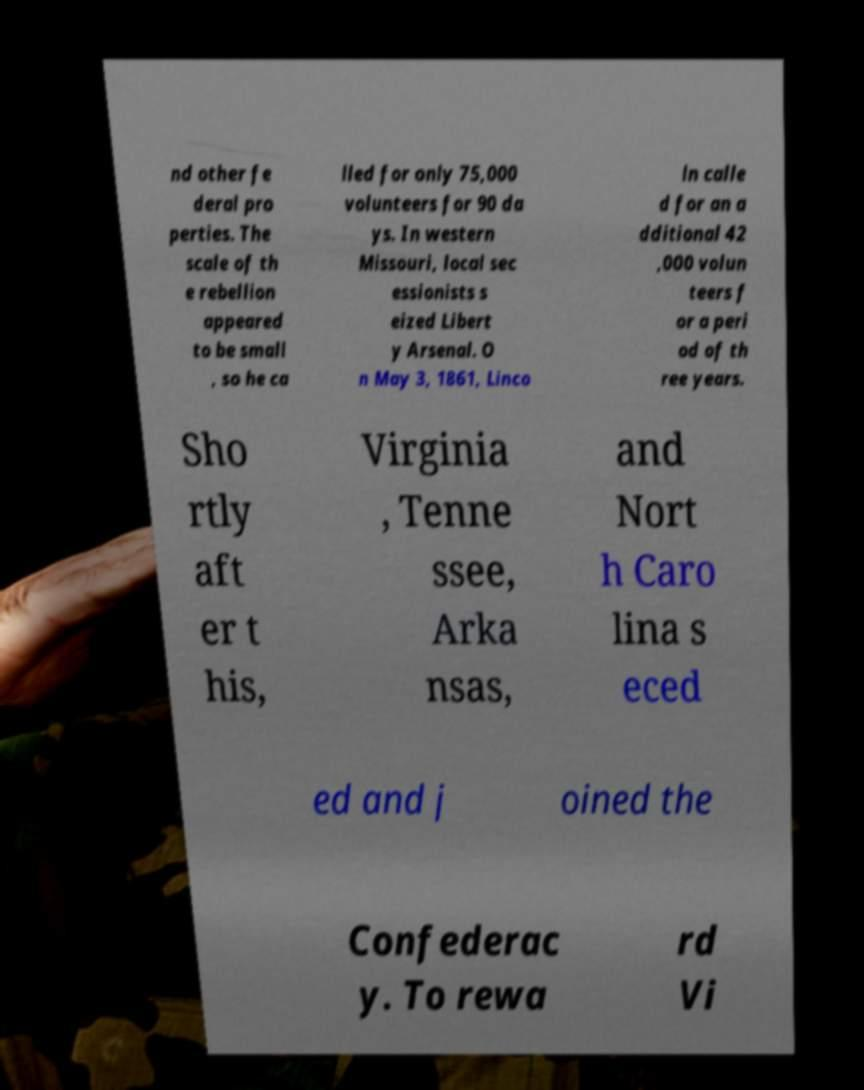There's text embedded in this image that I need extracted. Can you transcribe it verbatim? nd other fe deral pro perties. The scale of th e rebellion appeared to be small , so he ca lled for only 75,000 volunteers for 90 da ys. In western Missouri, local sec essionists s eized Libert y Arsenal. O n May 3, 1861, Linco ln calle d for an a dditional 42 ,000 volun teers f or a peri od of th ree years. Sho rtly aft er t his, Virginia , Tenne ssee, Arka nsas, and Nort h Caro lina s eced ed and j oined the Confederac y. To rewa rd Vi 